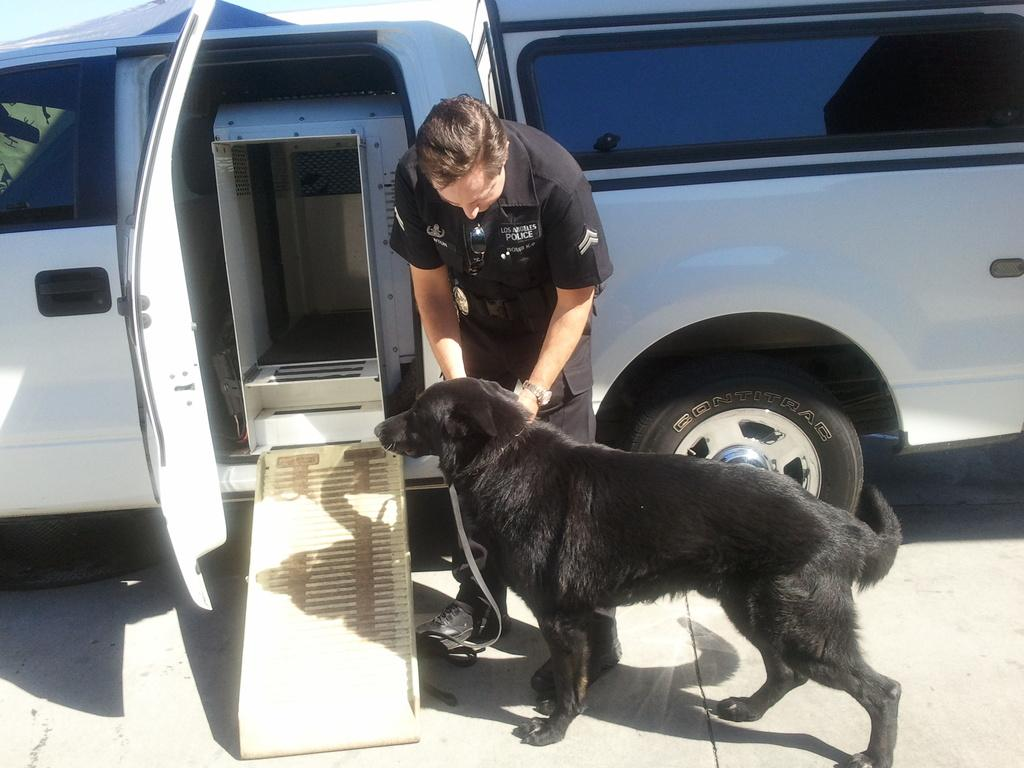What is the main object in the image? There is a vehicle in the image. Can you describe the person in the image? There is a person standing in the image. What is the person holding in the image? The person is holding a dog's belt. What type of snake can be seen climbing on the branch in the image? There is no snake or branch present in the image. How does the scale of the vehicle compare to the person in the image? The scale of the vehicle and the person cannot be determined from the image alone, as there is no reference point for comparison. 